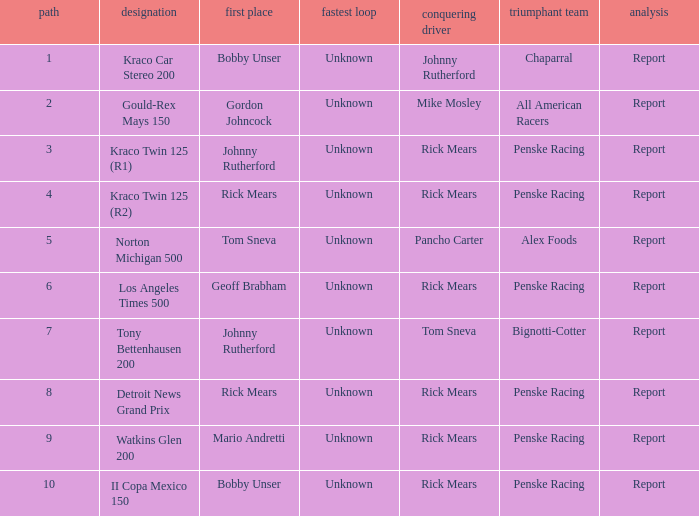Would you be able to parse every entry in this table? {'header': ['path', 'designation', 'first place', 'fastest loop', 'conquering driver', 'triumphant team', 'analysis'], 'rows': [['1', 'Kraco Car Stereo 200', 'Bobby Unser', 'Unknown', 'Johnny Rutherford', 'Chaparral', 'Report'], ['2', 'Gould-Rex Mays 150', 'Gordon Johncock', 'Unknown', 'Mike Mosley', 'All American Racers', 'Report'], ['3', 'Kraco Twin 125 (R1)', 'Johnny Rutherford', 'Unknown', 'Rick Mears', 'Penske Racing', 'Report'], ['4', 'Kraco Twin 125 (R2)', 'Rick Mears', 'Unknown', 'Rick Mears', 'Penske Racing', 'Report'], ['5', 'Norton Michigan 500', 'Tom Sneva', 'Unknown', 'Pancho Carter', 'Alex Foods', 'Report'], ['6', 'Los Angeles Times 500', 'Geoff Brabham', 'Unknown', 'Rick Mears', 'Penske Racing', 'Report'], ['7', 'Tony Bettenhausen 200', 'Johnny Rutherford', 'Unknown', 'Tom Sneva', 'Bignotti-Cotter', 'Report'], ['8', 'Detroit News Grand Prix', 'Rick Mears', 'Unknown', 'Rick Mears', 'Penske Racing', 'Report'], ['9', 'Watkins Glen 200', 'Mario Andretti', 'Unknown', 'Rick Mears', 'Penske Racing', 'Report'], ['10', 'II Copa Mexico 150', 'Bobby Unser', 'Unknown', 'Rick Mears', 'Penske Racing', 'Report']]} How many winning drivers in the kraco twin 125 (r2) race were there? 1.0. 